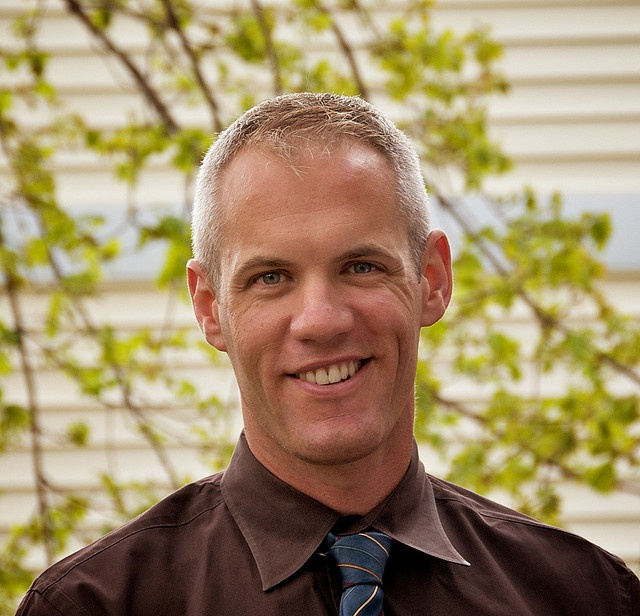Describe the objects in this image and their specific colors. I can see people in lightgray, black, brown, and maroon tones and tie in lightgray, black, darkblue, and gray tones in this image. 